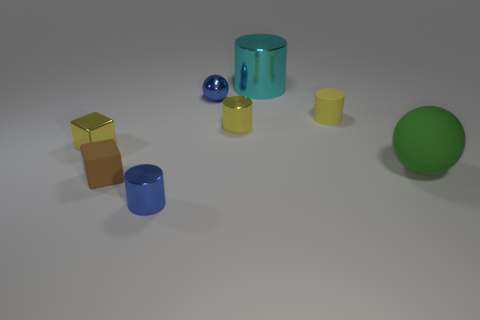Subtract all tiny cylinders. How many cylinders are left? 1 Add 2 red metal balls. How many objects exist? 10 Subtract all blue spheres. How many spheres are left? 1 Subtract all spheres. How many objects are left? 6 Subtract 1 spheres. How many spheres are left? 1 Subtract all yellow cylinders. Subtract all yellow spheres. How many cylinders are left? 2 Add 5 small blue spheres. How many small blue spheres are left? 6 Add 3 tiny blue objects. How many tiny blue objects exist? 5 Subtract 0 purple cylinders. How many objects are left? 8 Subtract all green blocks. How many blue cylinders are left? 1 